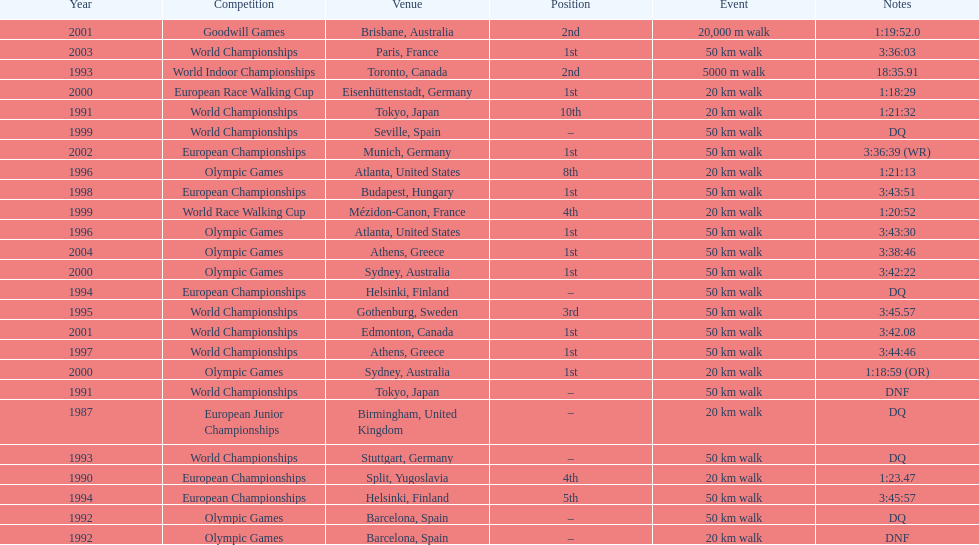Could you parse the entire table? {'header': ['Year', 'Competition', 'Venue', 'Position', 'Event', 'Notes'], 'rows': [['2001', 'Goodwill Games', 'Brisbane, Australia', '2nd', '20,000 m walk', '1:19:52.0'], ['2003', 'World Championships', 'Paris, France', '1st', '50\xa0km walk', '3:36:03'], ['1993', 'World Indoor Championships', 'Toronto, Canada', '2nd', '5000 m walk', '18:35.91'], ['2000', 'European Race Walking Cup', 'Eisenhüttenstadt, Germany', '1st', '20\xa0km walk', '1:18:29'], ['1991', 'World Championships', 'Tokyo, Japan', '10th', '20\xa0km walk', '1:21:32'], ['1999', 'World Championships', 'Seville, Spain', '–', '50\xa0km walk', 'DQ'], ['2002', 'European Championships', 'Munich, Germany', '1st', '50\xa0km walk', '3:36:39 (WR)'], ['1996', 'Olympic Games', 'Atlanta, United States', '8th', '20\xa0km walk', '1:21:13'], ['1998', 'European Championships', 'Budapest, Hungary', '1st', '50\xa0km walk', '3:43:51'], ['1999', 'World Race Walking Cup', 'Mézidon-Canon, France', '4th', '20\xa0km walk', '1:20:52'], ['1996', 'Olympic Games', 'Atlanta, United States', '1st', '50\xa0km walk', '3:43:30'], ['2004', 'Olympic Games', 'Athens, Greece', '1st', '50\xa0km walk', '3:38:46'], ['2000', 'Olympic Games', 'Sydney, Australia', '1st', '50\xa0km walk', '3:42:22'], ['1994', 'European Championships', 'Helsinki, Finland', '–', '50\xa0km walk', 'DQ'], ['1995', 'World Championships', 'Gothenburg, Sweden', '3rd', '50\xa0km walk', '3:45.57'], ['2001', 'World Championships', 'Edmonton, Canada', '1st', '50\xa0km walk', '3:42.08'], ['1997', 'World Championships', 'Athens, Greece', '1st', '50\xa0km walk', '3:44:46'], ['2000', 'Olympic Games', 'Sydney, Australia', '1st', '20\xa0km walk', '1:18:59 (OR)'], ['1991', 'World Championships', 'Tokyo, Japan', '–', '50\xa0km walk', 'DNF'], ['1987', 'European Junior Championships', 'Birmingham, United Kingdom', '–', '20\xa0km walk', 'DQ'], ['1993', 'World Championships', 'Stuttgart, Germany', '–', '50\xa0km walk', 'DQ'], ['1990', 'European Championships', 'Split, Yugoslavia', '4th', '20\xa0km walk', '1:23.47'], ['1994', 'European Championships', 'Helsinki, Finland', '5th', '50\xa0km walk', '3:45:57'], ['1992', 'Olympic Games', 'Barcelona, Spain', '–', '50\xa0km walk', 'DQ'], ['1992', 'Olympic Games', 'Barcelona, Spain', '–', '20\xa0km walk', 'DNF']]} Which venue is listed the most? Athens, Greece. 